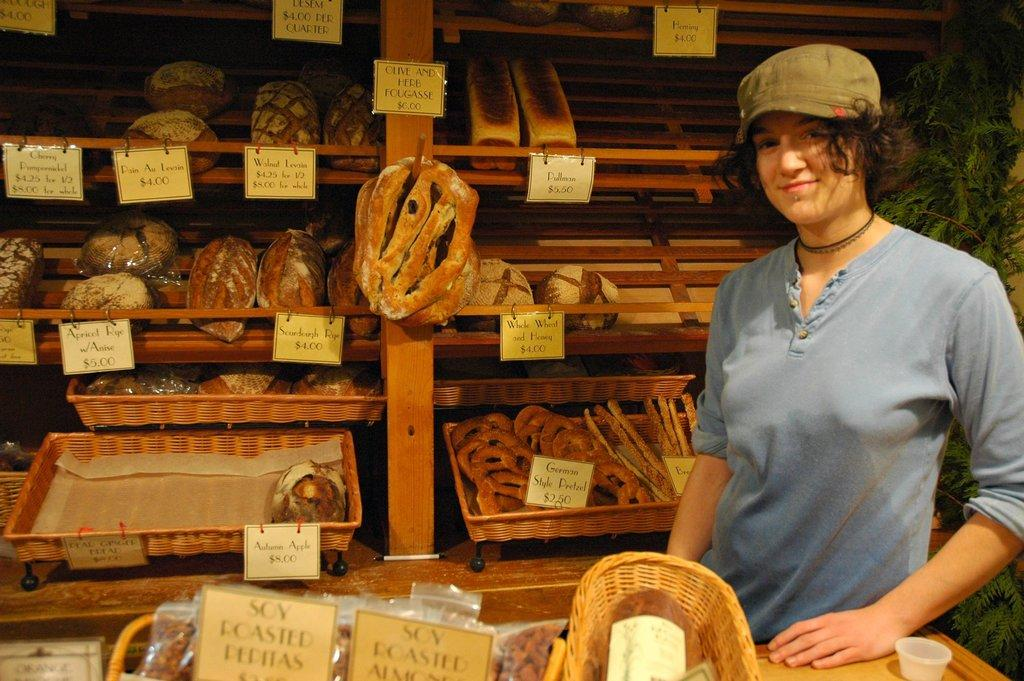<image>
Offer a succinct explanation of the picture presented. A woman at a stand selling things like German Style Pretzels for $2.50. 